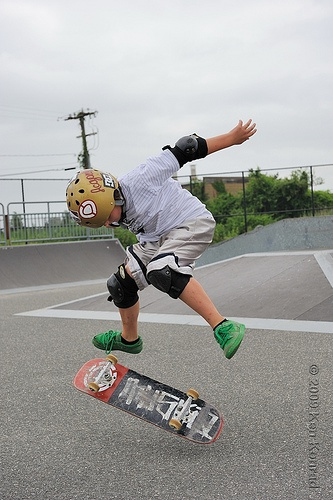Describe the objects in this image and their specific colors. I can see people in lightgray, darkgray, black, and gray tones and skateboard in lightgray, gray, darkgray, and black tones in this image. 